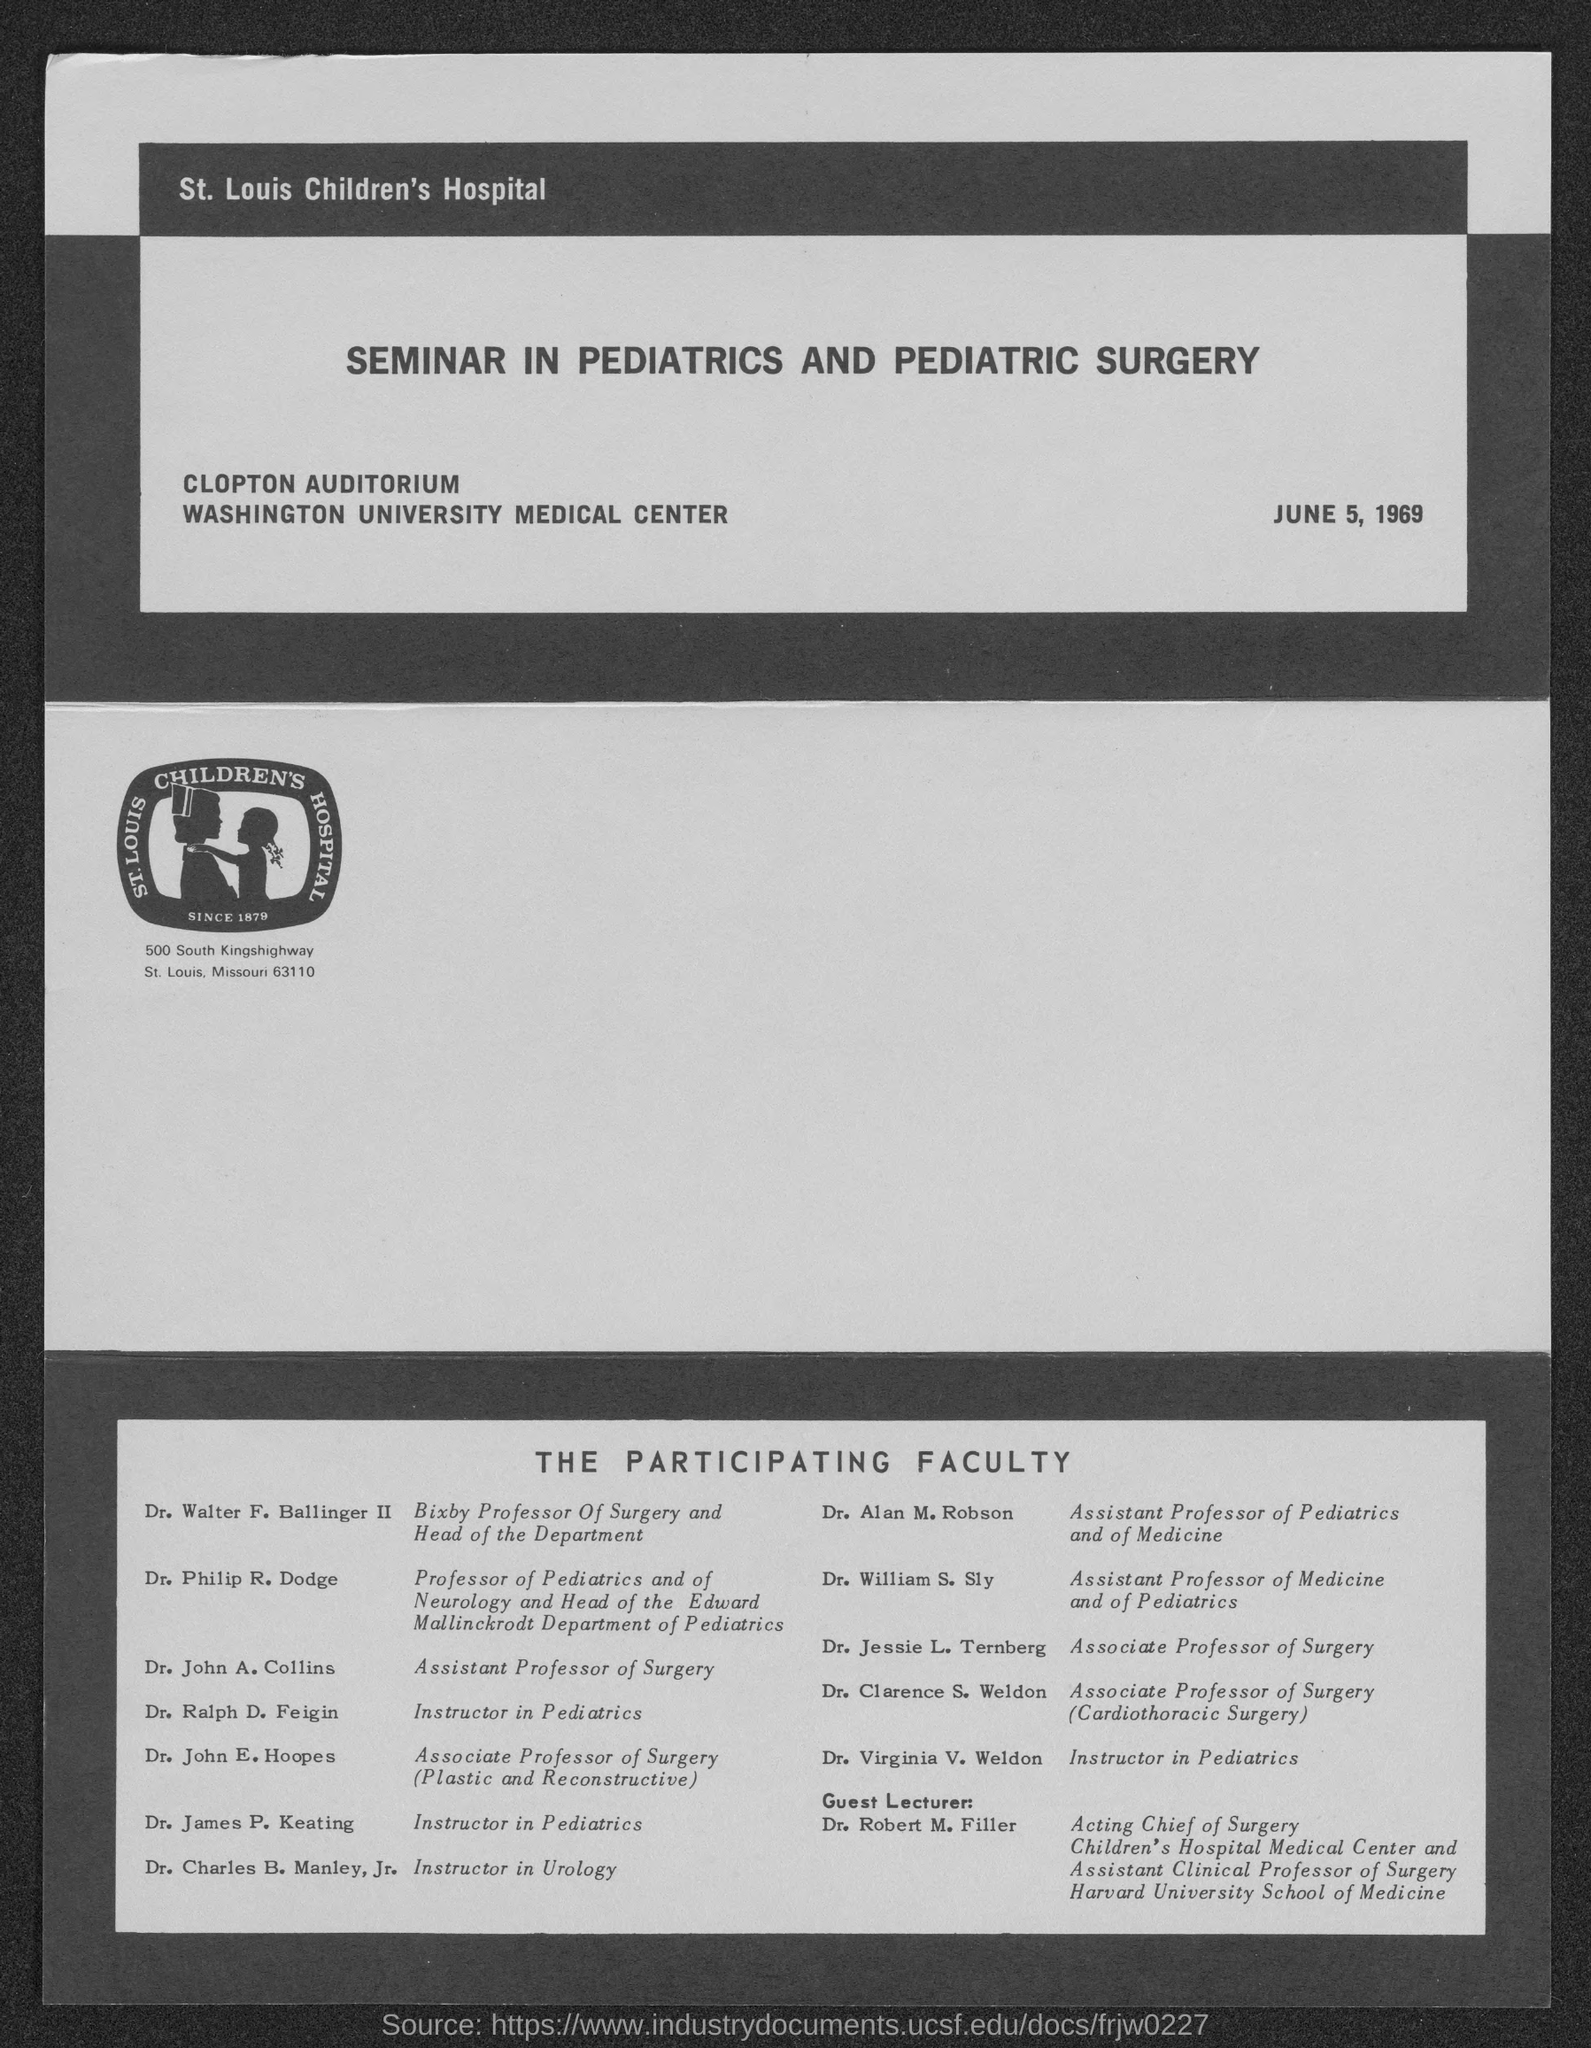Highlight a few significant elements in this photo. DR. ROBERT M. FILLER is the guest lecturer. St. Louis Children's Hospital is located at 500 South Kingshighway in St. Louis, Missouri, and its address is 500 South Kingshighway, St. Louis, Missouri 63110. 